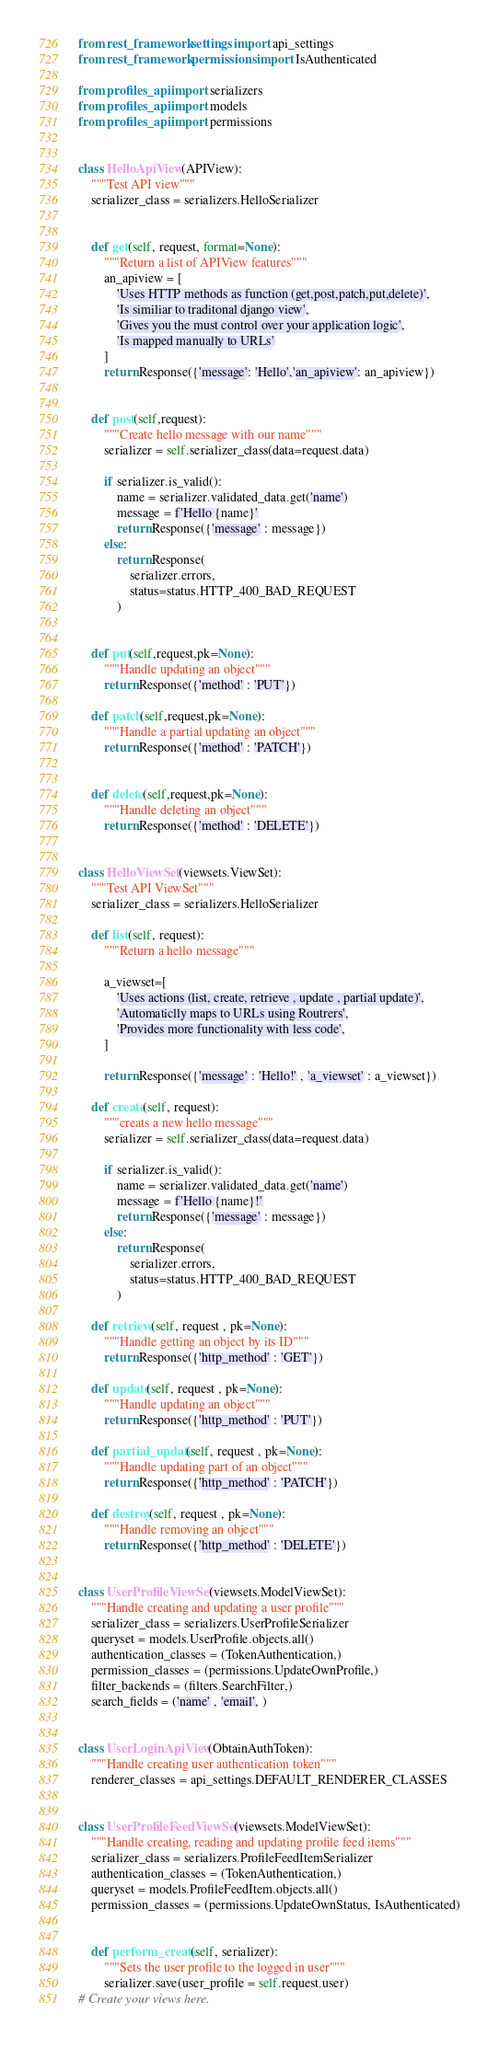<code> <loc_0><loc_0><loc_500><loc_500><_Python_>from rest_framework.settings import api_settings
from rest_framework.permissions import IsAuthenticated

from profiles_api import serializers
from profiles_api import models
from profiles_api import permissions


class HelloApiView(APIView):
    """Test API view"""
    serializer_class = serializers.HelloSerializer


    def get(self, request, format=None):
        """Return a list of APIView features"""
        an_apiview = [
            'Uses HTTP methods as function (get,post,patch,put,delete)',
            'Is similiar to traditonal django view',
            'Gives you the must control over your application logic',
            'Is mapped manually to URLs'
        ]
        return Response({'message': 'Hello','an_apiview': an_apiview})


    def post(self,request):
        """Create hello message with our name"""
        serializer = self.serializer_class(data=request.data)

        if serializer.is_valid():
            name = serializer.validated_data.get('name')
            message = f'Hello {name}'
            return Response({'message' : message})
        else:
            return Response(
                serializer.errors,
                status=status.HTTP_400_BAD_REQUEST
            )


    def put(self,request,pk=None):
        """Handle updating an object"""
        return Response({'method' : 'PUT'})

    def patch(self,request,pk=None):
        """Handle a partial updating an object"""
        return Response({'method' : 'PATCH'})


    def delete(self,request,pk=None):
        """Handle deleting an object"""
        return Response({'method' : 'DELETE'})


class HelloViewSet(viewsets.ViewSet):
    """Test API ViewSet"""
    serializer_class = serializers.HelloSerializer

    def list(self, request):
        """Return a hello message"""

        a_viewset=[
            'Uses actions (list, create, retrieve , update , partial update)',
            'Automaticlly maps to URLs using Routrers',
            'Provides more functionality with less code',
        ]

        return Response({'message' : 'Hello!' , 'a_viewset' : a_viewset})

    def create(self, request):
        """creats a new hello message"""
        serializer = self.serializer_class(data=request.data)

        if serializer.is_valid():
            name = serializer.validated_data.get('name')
            message = f'Hello {name}!'
            return Response({'message' : message})
        else:
            return Response(
                serializer.errors,
                status=status.HTTP_400_BAD_REQUEST
            )

    def retrieve(self, request , pk=None):
        """Handle getting an object by its ID"""
        return Response({'http_method' : 'GET'})

    def update(self, request , pk=None):
        """Handle updating an object"""
        return Response({'http_method' : 'PUT'})

    def partial_update(self, request , pk=None):
        """Handle updating part of an object"""
        return Response({'http_method' : 'PATCH'})

    def destroy(self, request , pk=None):
        """Handle removing an object"""
        return Response({'http_method' : 'DELETE'})


class UserProfileViewSet(viewsets.ModelViewSet):
    """Handle creating and updating a user profile"""
    serializer_class = serializers.UserProfileSerializer
    queryset = models.UserProfile.objects.all()
    authentication_classes = (TokenAuthentication,)
    permission_classes = (permissions.UpdateOwnProfile,)
    filter_backends = (filters.SearchFilter,)
    search_fields = ('name' , 'email', )


class UserLoginApiView(ObtainAuthToken):
    """Handle creating user authentication token"""
    renderer_classes = api_settings.DEFAULT_RENDERER_CLASSES


class UserProfileFeedViewSet(viewsets.ModelViewSet):
    """Handle creating, reading and updating profile feed items"""
    serializer_class = serializers.ProfileFeedItemSerializer
    authentication_classes = (TokenAuthentication,)
    queryset = models.ProfileFeedItem.objects.all()
    permission_classes = (permissions.UpdateOwnStatus, IsAuthenticated)


    def perform_create(self, serializer):
        """Sets the user profile to the logged in user"""
        serializer.save(user_profile = self.request.user)
# Create your views here.
</code> 